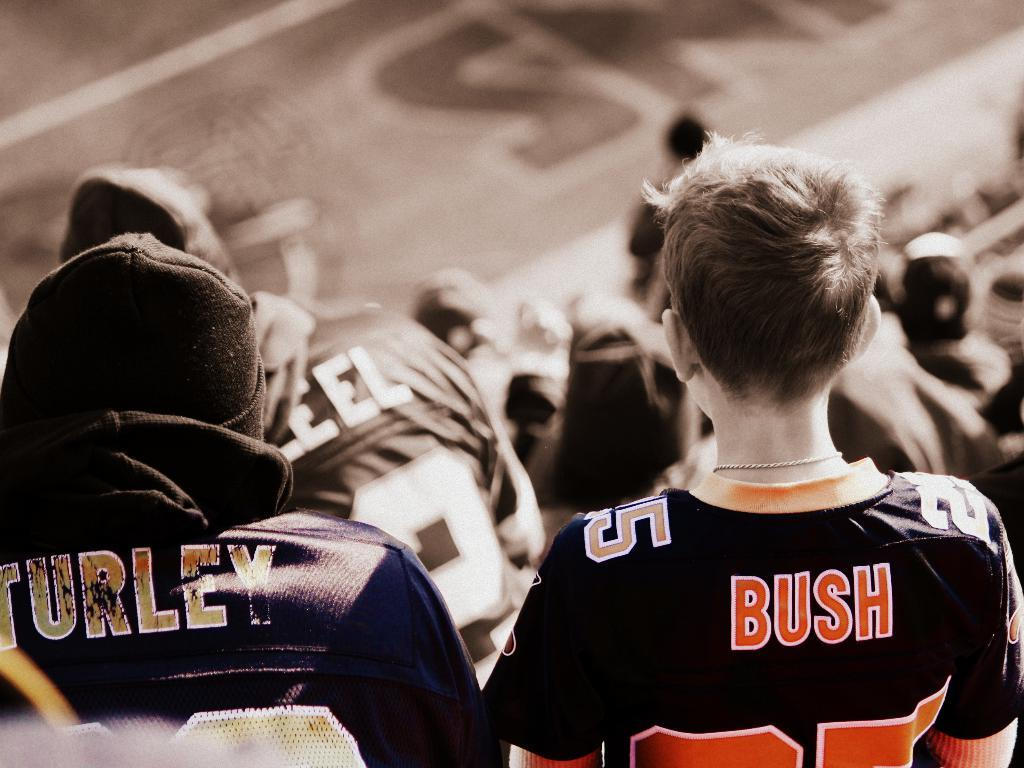<image>
Give a short and clear explanation of the subsequent image. two guys in the stands, one wearing turley jersey, another wearing bush jersey 